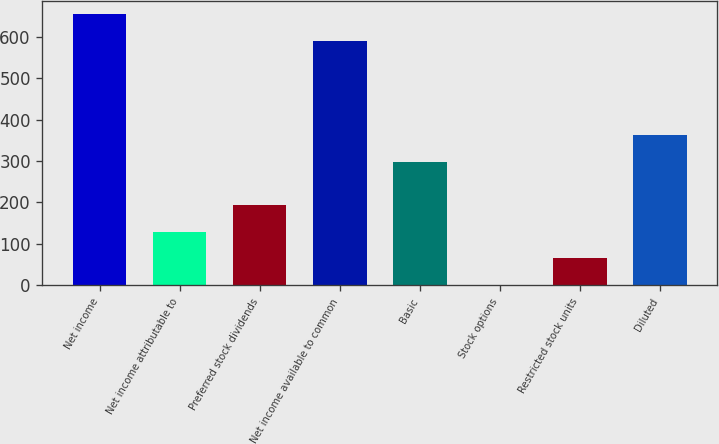Convert chart to OTSL. <chart><loc_0><loc_0><loc_500><loc_500><bar_chart><fcel>Net income<fcel>Net income attributable to<fcel>Preferred stock dividends<fcel>Net income available to common<fcel>Basic<fcel>Stock options<fcel>Restricted stock units<fcel>Diluted<nl><fcel>654.23<fcel>129.46<fcel>193.99<fcel>589.7<fcel>297.3<fcel>0.4<fcel>64.93<fcel>361.83<nl></chart> 